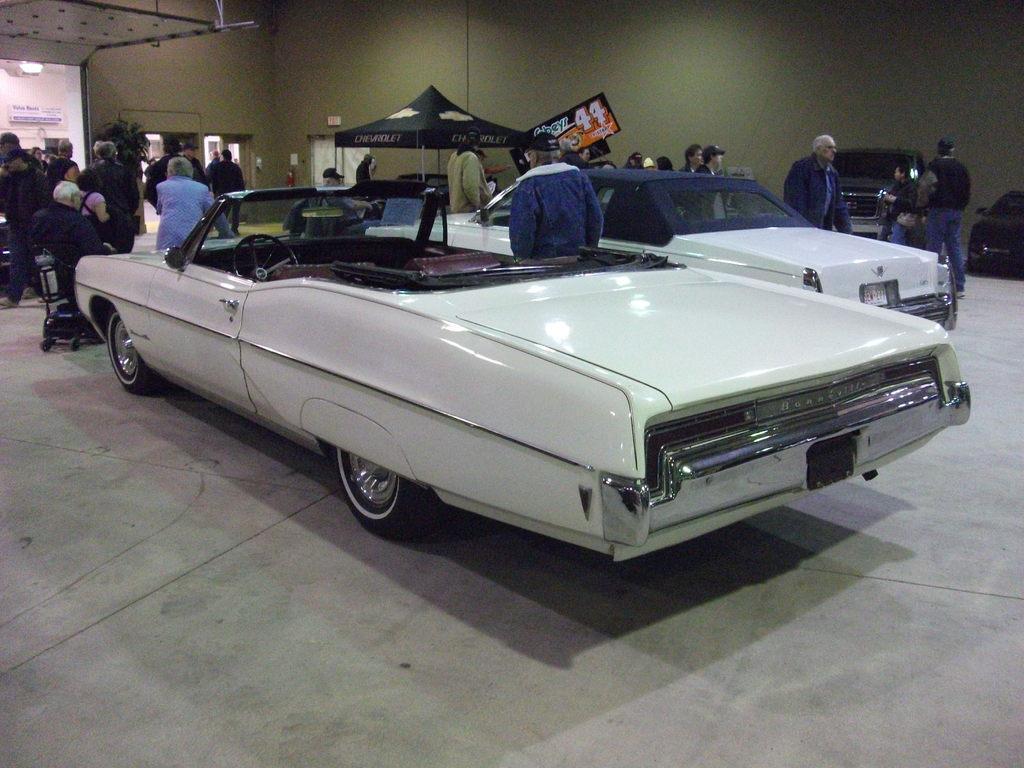How would you summarize this image in a sentence or two? In this image there are people, vehicles , tent in the foreground. And there are potted plants, a wall with some frames in the background. And there is floor at the bottom. 